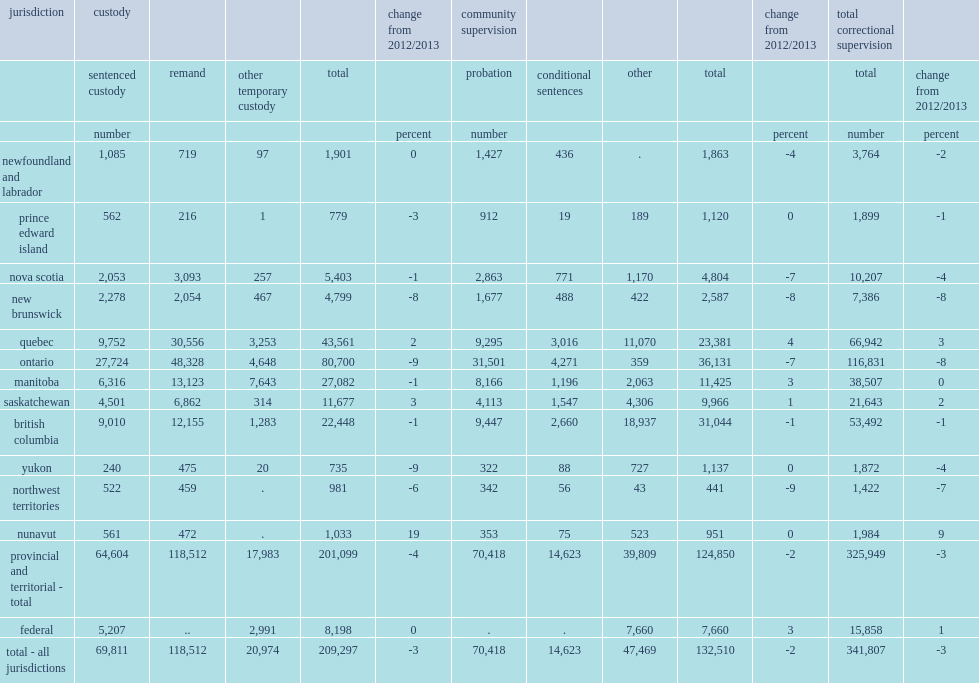In 2013/2014, what is number of the total admissions to federal and provincial/territorial adult correctional services in the 12 reporting provinces and territories? 341807.0. What is the decrease rate of total admissions in correctional supervision from the previous year in 2013/2014? 3. How many percent of all admissions was to provincial/territorial corrections? 0.953605. In the 12 reporting provinces and territories, what is the largest overall decrease rate from 2012/2013 in total correctional supervision? -8. In the 12 reporting provinces and territories, which region has recorded the largest overall decrease from 2012/2013 in total correctional supervision? New brunswick ontario. From 2012/2013 to 2013/2014, what is the largest increase in admissions to correctional supervision among 12 reporting provinces and territories? 9. From 2012/2013 to 2013/2014, which region has recorded the largest increase in admissions to correctional supervision among 12 reporting provinces and territories? Nunavut. 